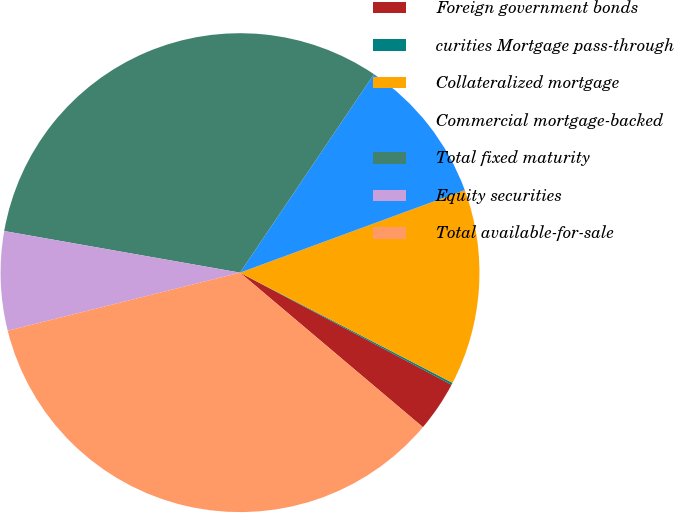Convert chart to OTSL. <chart><loc_0><loc_0><loc_500><loc_500><pie_chart><fcel>Foreign government bonds<fcel>curities Mortgage pass-through<fcel>Collateralized mortgage<fcel>Commercial mortgage-backed<fcel>Total fixed maturity<fcel>Equity securities<fcel>Total available-for-sale<nl><fcel>3.41%<fcel>0.14%<fcel>13.22%<fcel>9.95%<fcel>31.67%<fcel>6.68%<fcel>34.94%<nl></chart> 